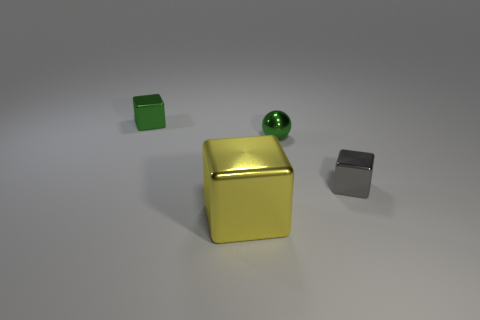Add 2 yellow metal things. How many objects exist? 6 Subtract all spheres. How many objects are left? 3 Add 1 tiny gray shiny cubes. How many tiny gray shiny cubes are left? 2 Add 3 big metal blocks. How many big metal blocks exist? 4 Subtract 1 green blocks. How many objects are left? 3 Subtract all yellow metal objects. Subtract all small blocks. How many objects are left? 1 